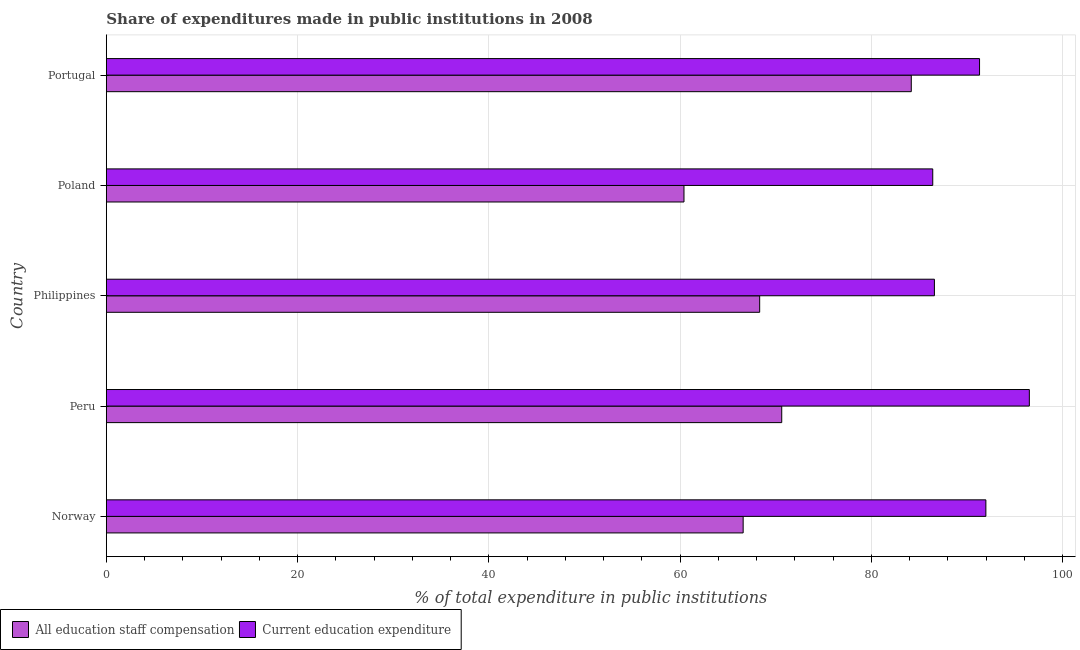How many different coloured bars are there?
Keep it short and to the point. 2. How many groups of bars are there?
Your answer should be compact. 5. Are the number of bars per tick equal to the number of legend labels?
Offer a terse response. Yes. How many bars are there on the 4th tick from the top?
Your answer should be compact. 2. How many bars are there on the 5th tick from the bottom?
Give a very brief answer. 2. What is the expenditure in staff compensation in Poland?
Your answer should be compact. 60.41. Across all countries, what is the maximum expenditure in education?
Provide a short and direct response. 96.53. Across all countries, what is the minimum expenditure in education?
Provide a short and direct response. 86.43. What is the total expenditure in education in the graph?
Ensure brevity in your answer.  452.87. What is the difference between the expenditure in education in Norway and that in Philippines?
Offer a terse response. 5.38. What is the difference between the expenditure in education in Norway and the expenditure in staff compensation in Philippines?
Provide a succinct answer. 23.66. What is the average expenditure in staff compensation per country?
Ensure brevity in your answer.  70.03. What is the difference between the expenditure in staff compensation and expenditure in education in Philippines?
Make the answer very short. -18.28. Is the expenditure in staff compensation in Peru less than that in Poland?
Your response must be concise. No. What is the difference between the highest and the second highest expenditure in staff compensation?
Your answer should be very brief. 13.55. What does the 1st bar from the top in Peru represents?
Ensure brevity in your answer.  Current education expenditure. What does the 1st bar from the bottom in Peru represents?
Provide a succinct answer. All education staff compensation. Are all the bars in the graph horizontal?
Offer a very short reply. Yes. What is the difference between two consecutive major ticks on the X-axis?
Give a very brief answer. 20. Does the graph contain grids?
Provide a short and direct response. Yes. Where does the legend appear in the graph?
Give a very brief answer. Bottom left. How many legend labels are there?
Your answer should be compact. 2. What is the title of the graph?
Your answer should be compact. Share of expenditures made in public institutions in 2008. Does "Gasoline" appear as one of the legend labels in the graph?
Provide a short and direct response. No. What is the label or title of the X-axis?
Ensure brevity in your answer.  % of total expenditure in public institutions. What is the % of total expenditure in public institutions of All education staff compensation in Norway?
Keep it short and to the point. 66.6. What is the % of total expenditure in public institutions in Current education expenditure in Norway?
Keep it short and to the point. 91.99. What is the % of total expenditure in public institutions of All education staff compensation in Peru?
Offer a very short reply. 70.64. What is the % of total expenditure in public institutions of Current education expenditure in Peru?
Your answer should be very brief. 96.53. What is the % of total expenditure in public institutions of All education staff compensation in Philippines?
Keep it short and to the point. 68.33. What is the % of total expenditure in public institutions of Current education expenditure in Philippines?
Give a very brief answer. 86.6. What is the % of total expenditure in public institutions of All education staff compensation in Poland?
Offer a terse response. 60.41. What is the % of total expenditure in public institutions of Current education expenditure in Poland?
Offer a very short reply. 86.43. What is the % of total expenditure in public institutions in All education staff compensation in Portugal?
Ensure brevity in your answer.  84.18. What is the % of total expenditure in public institutions in Current education expenditure in Portugal?
Ensure brevity in your answer.  91.32. Across all countries, what is the maximum % of total expenditure in public institutions of All education staff compensation?
Provide a succinct answer. 84.18. Across all countries, what is the maximum % of total expenditure in public institutions in Current education expenditure?
Give a very brief answer. 96.53. Across all countries, what is the minimum % of total expenditure in public institutions in All education staff compensation?
Your answer should be very brief. 60.41. Across all countries, what is the minimum % of total expenditure in public institutions in Current education expenditure?
Offer a very short reply. 86.43. What is the total % of total expenditure in public institutions in All education staff compensation in the graph?
Offer a terse response. 350.16. What is the total % of total expenditure in public institutions of Current education expenditure in the graph?
Your answer should be very brief. 452.87. What is the difference between the % of total expenditure in public institutions in All education staff compensation in Norway and that in Peru?
Your answer should be very brief. -4.04. What is the difference between the % of total expenditure in public institutions of Current education expenditure in Norway and that in Peru?
Provide a succinct answer. -4.55. What is the difference between the % of total expenditure in public institutions in All education staff compensation in Norway and that in Philippines?
Offer a terse response. -1.73. What is the difference between the % of total expenditure in public institutions in Current education expenditure in Norway and that in Philippines?
Your response must be concise. 5.38. What is the difference between the % of total expenditure in public institutions of All education staff compensation in Norway and that in Poland?
Provide a short and direct response. 6.19. What is the difference between the % of total expenditure in public institutions in Current education expenditure in Norway and that in Poland?
Your answer should be compact. 5.56. What is the difference between the % of total expenditure in public institutions of All education staff compensation in Norway and that in Portugal?
Provide a succinct answer. -17.58. What is the difference between the % of total expenditure in public institutions of Current education expenditure in Norway and that in Portugal?
Your response must be concise. 0.66. What is the difference between the % of total expenditure in public institutions in All education staff compensation in Peru and that in Philippines?
Your response must be concise. 2.31. What is the difference between the % of total expenditure in public institutions in Current education expenditure in Peru and that in Philippines?
Give a very brief answer. 9.93. What is the difference between the % of total expenditure in public institutions in All education staff compensation in Peru and that in Poland?
Your response must be concise. 10.22. What is the difference between the % of total expenditure in public institutions of Current education expenditure in Peru and that in Poland?
Your answer should be very brief. 10.1. What is the difference between the % of total expenditure in public institutions of All education staff compensation in Peru and that in Portugal?
Your answer should be compact. -13.55. What is the difference between the % of total expenditure in public institutions of Current education expenditure in Peru and that in Portugal?
Offer a terse response. 5.21. What is the difference between the % of total expenditure in public institutions in All education staff compensation in Philippines and that in Poland?
Keep it short and to the point. 7.92. What is the difference between the % of total expenditure in public institutions in Current education expenditure in Philippines and that in Poland?
Ensure brevity in your answer.  0.17. What is the difference between the % of total expenditure in public institutions in All education staff compensation in Philippines and that in Portugal?
Provide a short and direct response. -15.86. What is the difference between the % of total expenditure in public institutions of Current education expenditure in Philippines and that in Portugal?
Offer a very short reply. -4.72. What is the difference between the % of total expenditure in public institutions of All education staff compensation in Poland and that in Portugal?
Provide a short and direct response. -23.77. What is the difference between the % of total expenditure in public institutions of Current education expenditure in Poland and that in Portugal?
Offer a very short reply. -4.89. What is the difference between the % of total expenditure in public institutions of All education staff compensation in Norway and the % of total expenditure in public institutions of Current education expenditure in Peru?
Your response must be concise. -29.93. What is the difference between the % of total expenditure in public institutions in All education staff compensation in Norway and the % of total expenditure in public institutions in Current education expenditure in Philippines?
Your answer should be compact. -20. What is the difference between the % of total expenditure in public institutions of All education staff compensation in Norway and the % of total expenditure in public institutions of Current education expenditure in Poland?
Make the answer very short. -19.83. What is the difference between the % of total expenditure in public institutions of All education staff compensation in Norway and the % of total expenditure in public institutions of Current education expenditure in Portugal?
Your answer should be very brief. -24.72. What is the difference between the % of total expenditure in public institutions in All education staff compensation in Peru and the % of total expenditure in public institutions in Current education expenditure in Philippines?
Ensure brevity in your answer.  -15.97. What is the difference between the % of total expenditure in public institutions in All education staff compensation in Peru and the % of total expenditure in public institutions in Current education expenditure in Poland?
Make the answer very short. -15.79. What is the difference between the % of total expenditure in public institutions of All education staff compensation in Peru and the % of total expenditure in public institutions of Current education expenditure in Portugal?
Your response must be concise. -20.69. What is the difference between the % of total expenditure in public institutions of All education staff compensation in Philippines and the % of total expenditure in public institutions of Current education expenditure in Poland?
Provide a succinct answer. -18.1. What is the difference between the % of total expenditure in public institutions of All education staff compensation in Philippines and the % of total expenditure in public institutions of Current education expenditure in Portugal?
Your answer should be compact. -23. What is the difference between the % of total expenditure in public institutions in All education staff compensation in Poland and the % of total expenditure in public institutions in Current education expenditure in Portugal?
Your answer should be compact. -30.91. What is the average % of total expenditure in public institutions in All education staff compensation per country?
Offer a very short reply. 70.03. What is the average % of total expenditure in public institutions in Current education expenditure per country?
Your answer should be compact. 90.57. What is the difference between the % of total expenditure in public institutions in All education staff compensation and % of total expenditure in public institutions in Current education expenditure in Norway?
Provide a short and direct response. -25.39. What is the difference between the % of total expenditure in public institutions of All education staff compensation and % of total expenditure in public institutions of Current education expenditure in Peru?
Keep it short and to the point. -25.9. What is the difference between the % of total expenditure in public institutions of All education staff compensation and % of total expenditure in public institutions of Current education expenditure in Philippines?
Provide a short and direct response. -18.28. What is the difference between the % of total expenditure in public institutions in All education staff compensation and % of total expenditure in public institutions in Current education expenditure in Poland?
Offer a very short reply. -26.02. What is the difference between the % of total expenditure in public institutions of All education staff compensation and % of total expenditure in public institutions of Current education expenditure in Portugal?
Your answer should be compact. -7.14. What is the ratio of the % of total expenditure in public institutions in All education staff compensation in Norway to that in Peru?
Give a very brief answer. 0.94. What is the ratio of the % of total expenditure in public institutions of Current education expenditure in Norway to that in Peru?
Ensure brevity in your answer.  0.95. What is the ratio of the % of total expenditure in public institutions of All education staff compensation in Norway to that in Philippines?
Provide a succinct answer. 0.97. What is the ratio of the % of total expenditure in public institutions in Current education expenditure in Norway to that in Philippines?
Offer a terse response. 1.06. What is the ratio of the % of total expenditure in public institutions of All education staff compensation in Norway to that in Poland?
Provide a succinct answer. 1.1. What is the ratio of the % of total expenditure in public institutions of Current education expenditure in Norway to that in Poland?
Your answer should be compact. 1.06. What is the ratio of the % of total expenditure in public institutions in All education staff compensation in Norway to that in Portugal?
Make the answer very short. 0.79. What is the ratio of the % of total expenditure in public institutions in All education staff compensation in Peru to that in Philippines?
Provide a short and direct response. 1.03. What is the ratio of the % of total expenditure in public institutions in Current education expenditure in Peru to that in Philippines?
Offer a very short reply. 1.11. What is the ratio of the % of total expenditure in public institutions in All education staff compensation in Peru to that in Poland?
Provide a short and direct response. 1.17. What is the ratio of the % of total expenditure in public institutions in Current education expenditure in Peru to that in Poland?
Offer a terse response. 1.12. What is the ratio of the % of total expenditure in public institutions in All education staff compensation in Peru to that in Portugal?
Provide a short and direct response. 0.84. What is the ratio of the % of total expenditure in public institutions of Current education expenditure in Peru to that in Portugal?
Give a very brief answer. 1.06. What is the ratio of the % of total expenditure in public institutions of All education staff compensation in Philippines to that in Poland?
Ensure brevity in your answer.  1.13. What is the ratio of the % of total expenditure in public institutions in Current education expenditure in Philippines to that in Poland?
Keep it short and to the point. 1. What is the ratio of the % of total expenditure in public institutions of All education staff compensation in Philippines to that in Portugal?
Provide a succinct answer. 0.81. What is the ratio of the % of total expenditure in public institutions of Current education expenditure in Philippines to that in Portugal?
Provide a short and direct response. 0.95. What is the ratio of the % of total expenditure in public institutions in All education staff compensation in Poland to that in Portugal?
Provide a short and direct response. 0.72. What is the ratio of the % of total expenditure in public institutions in Current education expenditure in Poland to that in Portugal?
Your answer should be very brief. 0.95. What is the difference between the highest and the second highest % of total expenditure in public institutions in All education staff compensation?
Keep it short and to the point. 13.55. What is the difference between the highest and the second highest % of total expenditure in public institutions in Current education expenditure?
Provide a succinct answer. 4.55. What is the difference between the highest and the lowest % of total expenditure in public institutions of All education staff compensation?
Provide a short and direct response. 23.77. What is the difference between the highest and the lowest % of total expenditure in public institutions of Current education expenditure?
Your answer should be compact. 10.1. 